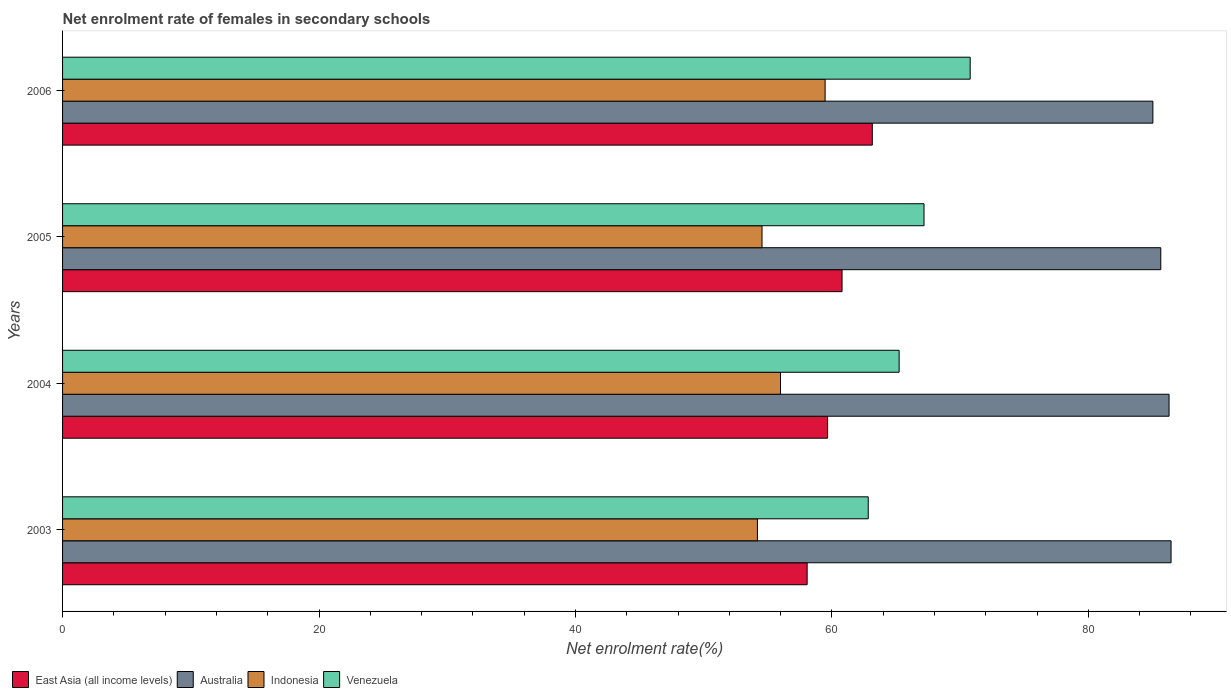How many different coloured bars are there?
Keep it short and to the point. 4. How many groups of bars are there?
Your response must be concise. 4. Are the number of bars on each tick of the Y-axis equal?
Offer a very short reply. Yes. How many bars are there on the 1st tick from the top?
Your answer should be compact. 4. How many bars are there on the 1st tick from the bottom?
Your answer should be very brief. 4. What is the label of the 1st group of bars from the top?
Your answer should be very brief. 2006. In how many cases, is the number of bars for a given year not equal to the number of legend labels?
Your answer should be compact. 0. What is the net enrolment rate of females in secondary schools in Venezuela in 2006?
Make the answer very short. 70.79. Across all years, what is the maximum net enrolment rate of females in secondary schools in Venezuela?
Your answer should be compact. 70.79. Across all years, what is the minimum net enrolment rate of females in secondary schools in East Asia (all income levels)?
Your response must be concise. 58.07. In which year was the net enrolment rate of females in secondary schools in Australia maximum?
Offer a terse response. 2003. What is the total net enrolment rate of females in secondary schools in East Asia (all income levels) in the graph?
Provide a succinct answer. 241.67. What is the difference between the net enrolment rate of females in secondary schools in Indonesia in 2003 and that in 2006?
Keep it short and to the point. -5.28. What is the difference between the net enrolment rate of females in secondary schools in Indonesia in 2004 and the net enrolment rate of females in secondary schools in Venezuela in 2005?
Your answer should be very brief. -11.19. What is the average net enrolment rate of females in secondary schools in Indonesia per year?
Keep it short and to the point. 56.05. In the year 2006, what is the difference between the net enrolment rate of females in secondary schools in Indonesia and net enrolment rate of females in secondary schools in Australia?
Provide a short and direct response. -25.56. What is the ratio of the net enrolment rate of females in secondary schools in Venezuela in 2004 to that in 2006?
Your answer should be compact. 0.92. Is the difference between the net enrolment rate of females in secondary schools in Indonesia in 2003 and 2006 greater than the difference between the net enrolment rate of females in secondary schools in Australia in 2003 and 2006?
Your answer should be compact. No. What is the difference between the highest and the second highest net enrolment rate of females in secondary schools in Indonesia?
Your response must be concise. 3.48. What is the difference between the highest and the lowest net enrolment rate of females in secondary schools in Venezuela?
Your response must be concise. 7.95. In how many years, is the net enrolment rate of females in secondary schools in Indonesia greater than the average net enrolment rate of females in secondary schools in Indonesia taken over all years?
Your answer should be compact. 1. Is it the case that in every year, the sum of the net enrolment rate of females in secondary schools in Venezuela and net enrolment rate of females in secondary schools in Indonesia is greater than the sum of net enrolment rate of females in secondary schools in Australia and net enrolment rate of females in secondary schools in East Asia (all income levels)?
Your answer should be very brief. No. What does the 4th bar from the top in 2003 represents?
Keep it short and to the point. East Asia (all income levels). What does the 1st bar from the bottom in 2006 represents?
Keep it short and to the point. East Asia (all income levels). How many bars are there?
Provide a short and direct response. 16. Are all the bars in the graph horizontal?
Keep it short and to the point. Yes. What is the difference between two consecutive major ticks on the X-axis?
Give a very brief answer. 20. Are the values on the major ticks of X-axis written in scientific E-notation?
Your response must be concise. No. Does the graph contain any zero values?
Offer a terse response. No. What is the title of the graph?
Provide a succinct answer. Net enrolment rate of females in secondary schools. Does "Andorra" appear as one of the legend labels in the graph?
Provide a short and direct response. No. What is the label or title of the X-axis?
Give a very brief answer. Net enrolment rate(%). What is the label or title of the Y-axis?
Your answer should be compact. Years. What is the Net enrolment rate(%) of East Asia (all income levels) in 2003?
Your answer should be compact. 58.07. What is the Net enrolment rate(%) of Australia in 2003?
Your answer should be compact. 86.45. What is the Net enrolment rate(%) in Indonesia in 2003?
Your response must be concise. 54.19. What is the Net enrolment rate(%) of Venezuela in 2003?
Provide a short and direct response. 62.83. What is the Net enrolment rate(%) in East Asia (all income levels) in 2004?
Your response must be concise. 59.67. What is the Net enrolment rate(%) of Australia in 2004?
Keep it short and to the point. 86.3. What is the Net enrolment rate(%) of Indonesia in 2004?
Provide a short and direct response. 55.99. What is the Net enrolment rate(%) of Venezuela in 2004?
Provide a short and direct response. 65.24. What is the Net enrolment rate(%) of East Asia (all income levels) in 2005?
Provide a short and direct response. 60.79. What is the Net enrolment rate(%) in Australia in 2005?
Offer a very short reply. 85.65. What is the Net enrolment rate(%) of Indonesia in 2005?
Offer a terse response. 54.55. What is the Net enrolment rate(%) of Venezuela in 2005?
Your answer should be compact. 67.18. What is the Net enrolment rate(%) of East Asia (all income levels) in 2006?
Your answer should be compact. 63.15. What is the Net enrolment rate(%) of Australia in 2006?
Your answer should be compact. 85.03. What is the Net enrolment rate(%) in Indonesia in 2006?
Ensure brevity in your answer.  59.47. What is the Net enrolment rate(%) of Venezuela in 2006?
Your response must be concise. 70.79. Across all years, what is the maximum Net enrolment rate(%) of East Asia (all income levels)?
Keep it short and to the point. 63.15. Across all years, what is the maximum Net enrolment rate(%) in Australia?
Offer a very short reply. 86.45. Across all years, what is the maximum Net enrolment rate(%) in Indonesia?
Your answer should be very brief. 59.47. Across all years, what is the maximum Net enrolment rate(%) of Venezuela?
Offer a very short reply. 70.79. Across all years, what is the minimum Net enrolment rate(%) in East Asia (all income levels)?
Offer a very short reply. 58.07. Across all years, what is the minimum Net enrolment rate(%) of Australia?
Provide a succinct answer. 85.03. Across all years, what is the minimum Net enrolment rate(%) in Indonesia?
Provide a succinct answer. 54.19. Across all years, what is the minimum Net enrolment rate(%) of Venezuela?
Your response must be concise. 62.83. What is the total Net enrolment rate(%) of East Asia (all income levels) in the graph?
Offer a very short reply. 241.67. What is the total Net enrolment rate(%) in Australia in the graph?
Provide a succinct answer. 343.43. What is the total Net enrolment rate(%) of Indonesia in the graph?
Offer a very short reply. 224.2. What is the total Net enrolment rate(%) of Venezuela in the graph?
Provide a short and direct response. 266.05. What is the difference between the Net enrolment rate(%) in East Asia (all income levels) in 2003 and that in 2004?
Ensure brevity in your answer.  -1.6. What is the difference between the Net enrolment rate(%) of Australia in 2003 and that in 2004?
Offer a terse response. 0.16. What is the difference between the Net enrolment rate(%) of Indonesia in 2003 and that in 2004?
Provide a short and direct response. -1.8. What is the difference between the Net enrolment rate(%) in Venezuela in 2003 and that in 2004?
Offer a very short reply. -2.41. What is the difference between the Net enrolment rate(%) of East Asia (all income levels) in 2003 and that in 2005?
Your answer should be compact. -2.72. What is the difference between the Net enrolment rate(%) in Australia in 2003 and that in 2005?
Your answer should be compact. 0.8. What is the difference between the Net enrolment rate(%) of Indonesia in 2003 and that in 2005?
Your response must be concise. -0.36. What is the difference between the Net enrolment rate(%) in Venezuela in 2003 and that in 2005?
Your answer should be compact. -4.35. What is the difference between the Net enrolment rate(%) in East Asia (all income levels) in 2003 and that in 2006?
Make the answer very short. -5.08. What is the difference between the Net enrolment rate(%) in Australia in 2003 and that in 2006?
Ensure brevity in your answer.  1.42. What is the difference between the Net enrolment rate(%) of Indonesia in 2003 and that in 2006?
Give a very brief answer. -5.28. What is the difference between the Net enrolment rate(%) of Venezuela in 2003 and that in 2006?
Provide a short and direct response. -7.95. What is the difference between the Net enrolment rate(%) of East Asia (all income levels) in 2004 and that in 2005?
Provide a succinct answer. -1.13. What is the difference between the Net enrolment rate(%) of Australia in 2004 and that in 2005?
Your answer should be compact. 0.65. What is the difference between the Net enrolment rate(%) in Indonesia in 2004 and that in 2005?
Offer a terse response. 1.44. What is the difference between the Net enrolment rate(%) in Venezuela in 2004 and that in 2005?
Your response must be concise. -1.94. What is the difference between the Net enrolment rate(%) in East Asia (all income levels) in 2004 and that in 2006?
Provide a succinct answer. -3.49. What is the difference between the Net enrolment rate(%) in Australia in 2004 and that in 2006?
Provide a short and direct response. 1.26. What is the difference between the Net enrolment rate(%) of Indonesia in 2004 and that in 2006?
Give a very brief answer. -3.48. What is the difference between the Net enrolment rate(%) of Venezuela in 2004 and that in 2006?
Offer a terse response. -5.54. What is the difference between the Net enrolment rate(%) of East Asia (all income levels) in 2005 and that in 2006?
Your answer should be compact. -2.36. What is the difference between the Net enrolment rate(%) in Australia in 2005 and that in 2006?
Offer a terse response. 0.62. What is the difference between the Net enrolment rate(%) in Indonesia in 2005 and that in 2006?
Offer a terse response. -4.92. What is the difference between the Net enrolment rate(%) of Venezuela in 2005 and that in 2006?
Your answer should be very brief. -3.6. What is the difference between the Net enrolment rate(%) of East Asia (all income levels) in 2003 and the Net enrolment rate(%) of Australia in 2004?
Your answer should be compact. -28.23. What is the difference between the Net enrolment rate(%) of East Asia (all income levels) in 2003 and the Net enrolment rate(%) of Indonesia in 2004?
Offer a terse response. 2.08. What is the difference between the Net enrolment rate(%) in East Asia (all income levels) in 2003 and the Net enrolment rate(%) in Venezuela in 2004?
Your answer should be compact. -7.17. What is the difference between the Net enrolment rate(%) in Australia in 2003 and the Net enrolment rate(%) in Indonesia in 2004?
Ensure brevity in your answer.  30.46. What is the difference between the Net enrolment rate(%) in Australia in 2003 and the Net enrolment rate(%) in Venezuela in 2004?
Make the answer very short. 21.21. What is the difference between the Net enrolment rate(%) of Indonesia in 2003 and the Net enrolment rate(%) of Venezuela in 2004?
Offer a very short reply. -11.05. What is the difference between the Net enrolment rate(%) in East Asia (all income levels) in 2003 and the Net enrolment rate(%) in Australia in 2005?
Your response must be concise. -27.58. What is the difference between the Net enrolment rate(%) in East Asia (all income levels) in 2003 and the Net enrolment rate(%) in Indonesia in 2005?
Offer a very short reply. 3.52. What is the difference between the Net enrolment rate(%) of East Asia (all income levels) in 2003 and the Net enrolment rate(%) of Venezuela in 2005?
Provide a succinct answer. -9.12. What is the difference between the Net enrolment rate(%) of Australia in 2003 and the Net enrolment rate(%) of Indonesia in 2005?
Your answer should be very brief. 31.9. What is the difference between the Net enrolment rate(%) of Australia in 2003 and the Net enrolment rate(%) of Venezuela in 2005?
Make the answer very short. 19.27. What is the difference between the Net enrolment rate(%) of Indonesia in 2003 and the Net enrolment rate(%) of Venezuela in 2005?
Keep it short and to the point. -12.99. What is the difference between the Net enrolment rate(%) in East Asia (all income levels) in 2003 and the Net enrolment rate(%) in Australia in 2006?
Provide a short and direct response. -26.97. What is the difference between the Net enrolment rate(%) of East Asia (all income levels) in 2003 and the Net enrolment rate(%) of Indonesia in 2006?
Offer a terse response. -1.4. What is the difference between the Net enrolment rate(%) in East Asia (all income levels) in 2003 and the Net enrolment rate(%) in Venezuela in 2006?
Give a very brief answer. -12.72. What is the difference between the Net enrolment rate(%) in Australia in 2003 and the Net enrolment rate(%) in Indonesia in 2006?
Your response must be concise. 26.98. What is the difference between the Net enrolment rate(%) of Australia in 2003 and the Net enrolment rate(%) of Venezuela in 2006?
Make the answer very short. 15.67. What is the difference between the Net enrolment rate(%) of Indonesia in 2003 and the Net enrolment rate(%) of Venezuela in 2006?
Your answer should be compact. -16.59. What is the difference between the Net enrolment rate(%) in East Asia (all income levels) in 2004 and the Net enrolment rate(%) in Australia in 2005?
Offer a terse response. -25.98. What is the difference between the Net enrolment rate(%) in East Asia (all income levels) in 2004 and the Net enrolment rate(%) in Indonesia in 2005?
Provide a short and direct response. 5.12. What is the difference between the Net enrolment rate(%) in East Asia (all income levels) in 2004 and the Net enrolment rate(%) in Venezuela in 2005?
Give a very brief answer. -7.52. What is the difference between the Net enrolment rate(%) of Australia in 2004 and the Net enrolment rate(%) of Indonesia in 2005?
Provide a succinct answer. 31.75. What is the difference between the Net enrolment rate(%) in Australia in 2004 and the Net enrolment rate(%) in Venezuela in 2005?
Offer a very short reply. 19.11. What is the difference between the Net enrolment rate(%) of Indonesia in 2004 and the Net enrolment rate(%) of Venezuela in 2005?
Ensure brevity in your answer.  -11.19. What is the difference between the Net enrolment rate(%) in East Asia (all income levels) in 2004 and the Net enrolment rate(%) in Australia in 2006?
Ensure brevity in your answer.  -25.37. What is the difference between the Net enrolment rate(%) in East Asia (all income levels) in 2004 and the Net enrolment rate(%) in Indonesia in 2006?
Give a very brief answer. 0.2. What is the difference between the Net enrolment rate(%) of East Asia (all income levels) in 2004 and the Net enrolment rate(%) of Venezuela in 2006?
Keep it short and to the point. -11.12. What is the difference between the Net enrolment rate(%) in Australia in 2004 and the Net enrolment rate(%) in Indonesia in 2006?
Keep it short and to the point. 26.83. What is the difference between the Net enrolment rate(%) in Australia in 2004 and the Net enrolment rate(%) in Venezuela in 2006?
Your answer should be very brief. 15.51. What is the difference between the Net enrolment rate(%) of Indonesia in 2004 and the Net enrolment rate(%) of Venezuela in 2006?
Offer a terse response. -14.79. What is the difference between the Net enrolment rate(%) of East Asia (all income levels) in 2005 and the Net enrolment rate(%) of Australia in 2006?
Provide a succinct answer. -24.24. What is the difference between the Net enrolment rate(%) of East Asia (all income levels) in 2005 and the Net enrolment rate(%) of Indonesia in 2006?
Your answer should be compact. 1.32. What is the difference between the Net enrolment rate(%) of East Asia (all income levels) in 2005 and the Net enrolment rate(%) of Venezuela in 2006?
Make the answer very short. -9.99. What is the difference between the Net enrolment rate(%) of Australia in 2005 and the Net enrolment rate(%) of Indonesia in 2006?
Give a very brief answer. 26.18. What is the difference between the Net enrolment rate(%) in Australia in 2005 and the Net enrolment rate(%) in Venezuela in 2006?
Make the answer very short. 14.86. What is the difference between the Net enrolment rate(%) of Indonesia in 2005 and the Net enrolment rate(%) of Venezuela in 2006?
Offer a very short reply. -16.23. What is the average Net enrolment rate(%) of East Asia (all income levels) per year?
Make the answer very short. 60.42. What is the average Net enrolment rate(%) in Australia per year?
Keep it short and to the point. 85.86. What is the average Net enrolment rate(%) in Indonesia per year?
Provide a succinct answer. 56.05. What is the average Net enrolment rate(%) in Venezuela per year?
Provide a short and direct response. 66.51. In the year 2003, what is the difference between the Net enrolment rate(%) in East Asia (all income levels) and Net enrolment rate(%) in Australia?
Offer a very short reply. -28.38. In the year 2003, what is the difference between the Net enrolment rate(%) of East Asia (all income levels) and Net enrolment rate(%) of Indonesia?
Offer a very short reply. 3.88. In the year 2003, what is the difference between the Net enrolment rate(%) of East Asia (all income levels) and Net enrolment rate(%) of Venezuela?
Offer a terse response. -4.77. In the year 2003, what is the difference between the Net enrolment rate(%) of Australia and Net enrolment rate(%) of Indonesia?
Offer a terse response. 32.26. In the year 2003, what is the difference between the Net enrolment rate(%) of Australia and Net enrolment rate(%) of Venezuela?
Offer a terse response. 23.62. In the year 2003, what is the difference between the Net enrolment rate(%) in Indonesia and Net enrolment rate(%) in Venezuela?
Provide a short and direct response. -8.64. In the year 2004, what is the difference between the Net enrolment rate(%) in East Asia (all income levels) and Net enrolment rate(%) in Australia?
Offer a very short reply. -26.63. In the year 2004, what is the difference between the Net enrolment rate(%) in East Asia (all income levels) and Net enrolment rate(%) in Indonesia?
Ensure brevity in your answer.  3.67. In the year 2004, what is the difference between the Net enrolment rate(%) of East Asia (all income levels) and Net enrolment rate(%) of Venezuela?
Your answer should be compact. -5.58. In the year 2004, what is the difference between the Net enrolment rate(%) of Australia and Net enrolment rate(%) of Indonesia?
Give a very brief answer. 30.3. In the year 2004, what is the difference between the Net enrolment rate(%) in Australia and Net enrolment rate(%) in Venezuela?
Your answer should be very brief. 21.05. In the year 2004, what is the difference between the Net enrolment rate(%) in Indonesia and Net enrolment rate(%) in Venezuela?
Make the answer very short. -9.25. In the year 2005, what is the difference between the Net enrolment rate(%) of East Asia (all income levels) and Net enrolment rate(%) of Australia?
Offer a very short reply. -24.86. In the year 2005, what is the difference between the Net enrolment rate(%) in East Asia (all income levels) and Net enrolment rate(%) in Indonesia?
Provide a short and direct response. 6.24. In the year 2005, what is the difference between the Net enrolment rate(%) in East Asia (all income levels) and Net enrolment rate(%) in Venezuela?
Make the answer very short. -6.39. In the year 2005, what is the difference between the Net enrolment rate(%) in Australia and Net enrolment rate(%) in Indonesia?
Give a very brief answer. 31.1. In the year 2005, what is the difference between the Net enrolment rate(%) of Australia and Net enrolment rate(%) of Venezuela?
Ensure brevity in your answer.  18.46. In the year 2005, what is the difference between the Net enrolment rate(%) in Indonesia and Net enrolment rate(%) in Venezuela?
Provide a succinct answer. -12.63. In the year 2006, what is the difference between the Net enrolment rate(%) of East Asia (all income levels) and Net enrolment rate(%) of Australia?
Keep it short and to the point. -21.88. In the year 2006, what is the difference between the Net enrolment rate(%) of East Asia (all income levels) and Net enrolment rate(%) of Indonesia?
Your answer should be very brief. 3.68. In the year 2006, what is the difference between the Net enrolment rate(%) in East Asia (all income levels) and Net enrolment rate(%) in Venezuela?
Provide a short and direct response. -7.63. In the year 2006, what is the difference between the Net enrolment rate(%) of Australia and Net enrolment rate(%) of Indonesia?
Provide a succinct answer. 25.56. In the year 2006, what is the difference between the Net enrolment rate(%) in Australia and Net enrolment rate(%) in Venezuela?
Provide a short and direct response. 14.25. In the year 2006, what is the difference between the Net enrolment rate(%) in Indonesia and Net enrolment rate(%) in Venezuela?
Offer a terse response. -11.31. What is the ratio of the Net enrolment rate(%) of East Asia (all income levels) in 2003 to that in 2004?
Your answer should be very brief. 0.97. What is the ratio of the Net enrolment rate(%) of Indonesia in 2003 to that in 2004?
Keep it short and to the point. 0.97. What is the ratio of the Net enrolment rate(%) in Venezuela in 2003 to that in 2004?
Keep it short and to the point. 0.96. What is the ratio of the Net enrolment rate(%) of East Asia (all income levels) in 2003 to that in 2005?
Ensure brevity in your answer.  0.96. What is the ratio of the Net enrolment rate(%) in Australia in 2003 to that in 2005?
Offer a terse response. 1.01. What is the ratio of the Net enrolment rate(%) of Venezuela in 2003 to that in 2005?
Keep it short and to the point. 0.94. What is the ratio of the Net enrolment rate(%) of East Asia (all income levels) in 2003 to that in 2006?
Your answer should be compact. 0.92. What is the ratio of the Net enrolment rate(%) in Australia in 2003 to that in 2006?
Offer a terse response. 1.02. What is the ratio of the Net enrolment rate(%) of Indonesia in 2003 to that in 2006?
Offer a terse response. 0.91. What is the ratio of the Net enrolment rate(%) of Venezuela in 2003 to that in 2006?
Your answer should be very brief. 0.89. What is the ratio of the Net enrolment rate(%) in East Asia (all income levels) in 2004 to that in 2005?
Offer a terse response. 0.98. What is the ratio of the Net enrolment rate(%) of Australia in 2004 to that in 2005?
Ensure brevity in your answer.  1.01. What is the ratio of the Net enrolment rate(%) in Indonesia in 2004 to that in 2005?
Ensure brevity in your answer.  1.03. What is the ratio of the Net enrolment rate(%) in Venezuela in 2004 to that in 2005?
Provide a succinct answer. 0.97. What is the ratio of the Net enrolment rate(%) of East Asia (all income levels) in 2004 to that in 2006?
Provide a succinct answer. 0.94. What is the ratio of the Net enrolment rate(%) in Australia in 2004 to that in 2006?
Provide a succinct answer. 1.01. What is the ratio of the Net enrolment rate(%) in Indonesia in 2004 to that in 2006?
Offer a very short reply. 0.94. What is the ratio of the Net enrolment rate(%) in Venezuela in 2004 to that in 2006?
Keep it short and to the point. 0.92. What is the ratio of the Net enrolment rate(%) in East Asia (all income levels) in 2005 to that in 2006?
Keep it short and to the point. 0.96. What is the ratio of the Net enrolment rate(%) of Indonesia in 2005 to that in 2006?
Provide a succinct answer. 0.92. What is the ratio of the Net enrolment rate(%) in Venezuela in 2005 to that in 2006?
Ensure brevity in your answer.  0.95. What is the difference between the highest and the second highest Net enrolment rate(%) of East Asia (all income levels)?
Offer a very short reply. 2.36. What is the difference between the highest and the second highest Net enrolment rate(%) of Australia?
Make the answer very short. 0.16. What is the difference between the highest and the second highest Net enrolment rate(%) in Indonesia?
Ensure brevity in your answer.  3.48. What is the difference between the highest and the second highest Net enrolment rate(%) in Venezuela?
Give a very brief answer. 3.6. What is the difference between the highest and the lowest Net enrolment rate(%) in East Asia (all income levels)?
Ensure brevity in your answer.  5.08. What is the difference between the highest and the lowest Net enrolment rate(%) in Australia?
Provide a succinct answer. 1.42. What is the difference between the highest and the lowest Net enrolment rate(%) in Indonesia?
Provide a short and direct response. 5.28. What is the difference between the highest and the lowest Net enrolment rate(%) in Venezuela?
Provide a succinct answer. 7.95. 